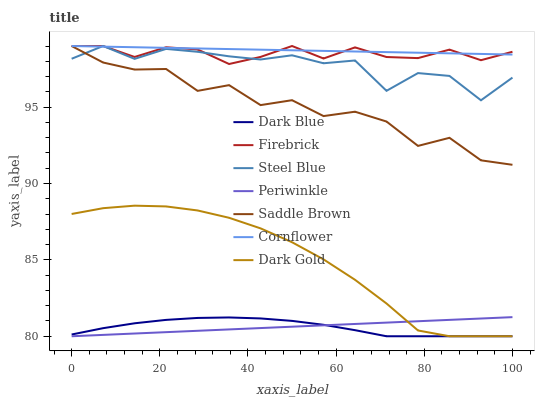Does Dark Gold have the minimum area under the curve?
Answer yes or no. No. Does Dark Gold have the maximum area under the curve?
Answer yes or no. No. Is Dark Gold the smoothest?
Answer yes or no. No. Is Dark Gold the roughest?
Answer yes or no. No. Does Firebrick have the lowest value?
Answer yes or no. No. Does Dark Gold have the highest value?
Answer yes or no. No. Is Periwinkle less than Cornflower?
Answer yes or no. Yes. Is Firebrick greater than Periwinkle?
Answer yes or no. Yes. Does Periwinkle intersect Cornflower?
Answer yes or no. No. 